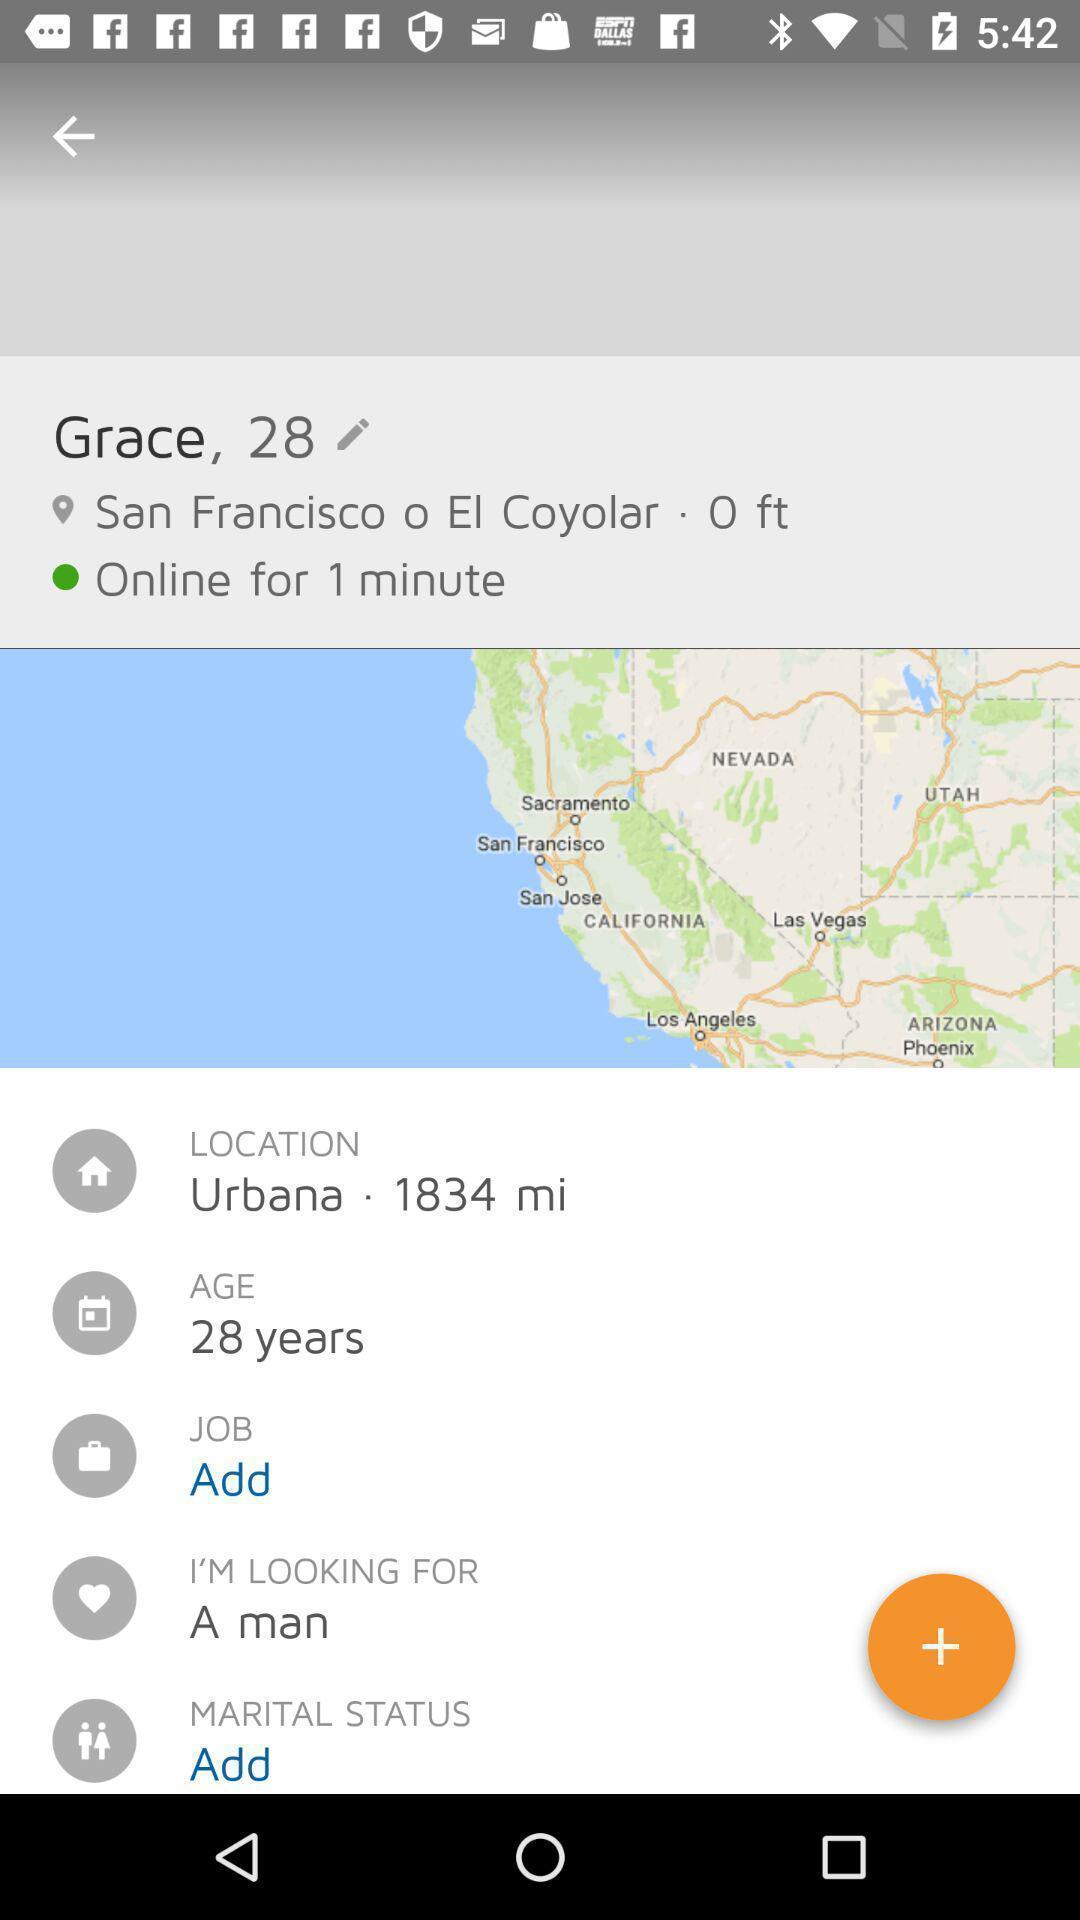Explain what's happening in this screen capture. Page shows the location in an social application. 